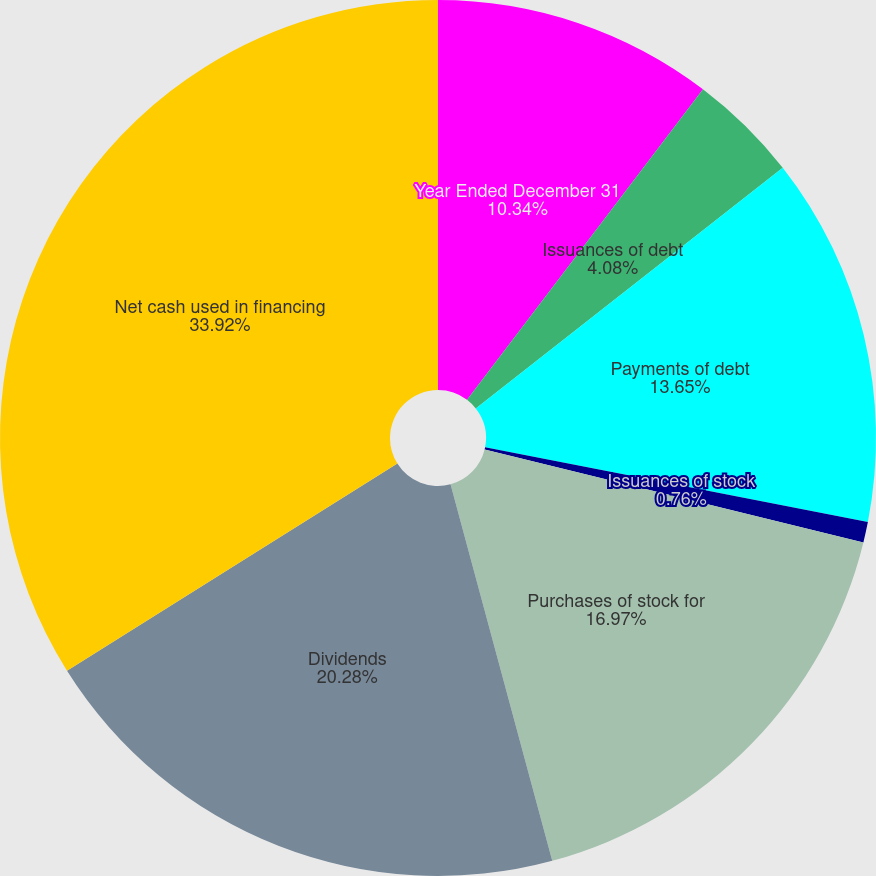Convert chart to OTSL. <chart><loc_0><loc_0><loc_500><loc_500><pie_chart><fcel>Year Ended December 31<fcel>Issuances of debt<fcel>Payments of debt<fcel>Issuances of stock<fcel>Purchases of stock for<fcel>Dividends<fcel>Net cash used in financing<nl><fcel>10.34%<fcel>4.08%<fcel>13.65%<fcel>0.76%<fcel>16.97%<fcel>20.28%<fcel>33.92%<nl></chart> 